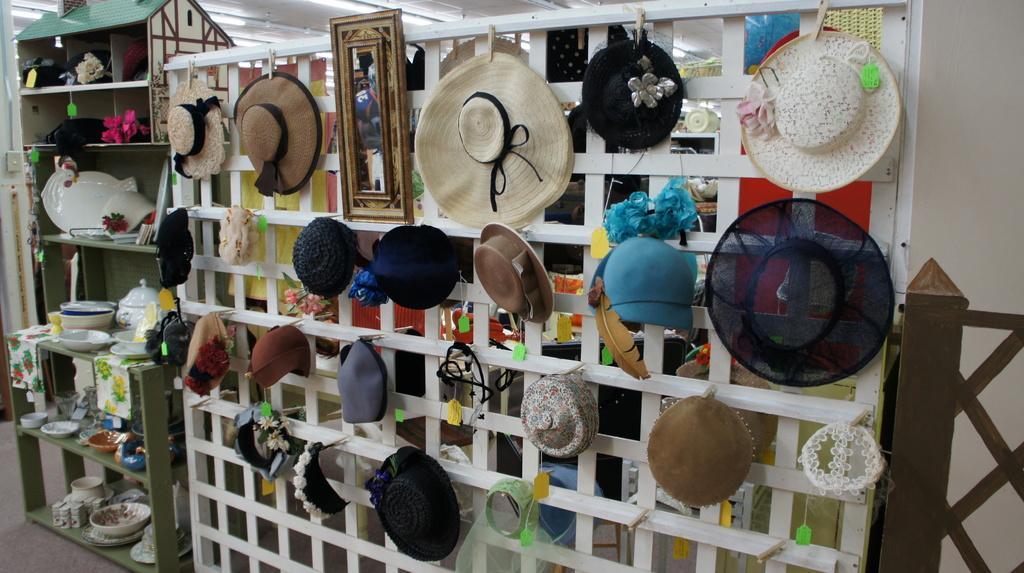Can you describe this image briefly? In this image, we can see a grill. On the grill we can see few caps and hats are hanging with the help of clips. On the left side, we can see racks. Few things and objects are placed on it. Here we can see a mirror. Top of the image, we can see the lights. Right side of the image, we can see a wall and painting. 